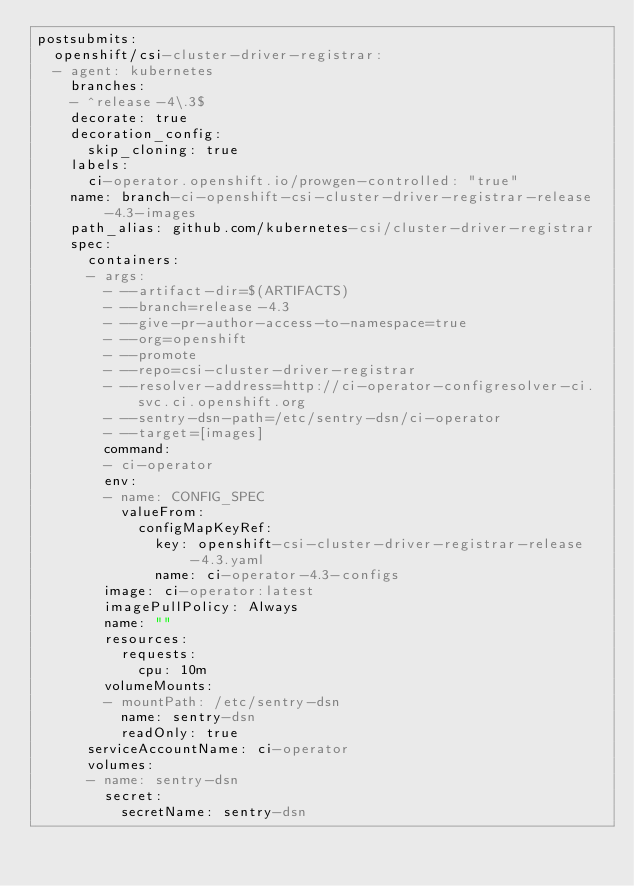Convert code to text. <code><loc_0><loc_0><loc_500><loc_500><_YAML_>postsubmits:
  openshift/csi-cluster-driver-registrar:
  - agent: kubernetes
    branches:
    - ^release-4\.3$
    decorate: true
    decoration_config:
      skip_cloning: true
    labels:
      ci-operator.openshift.io/prowgen-controlled: "true"
    name: branch-ci-openshift-csi-cluster-driver-registrar-release-4.3-images
    path_alias: github.com/kubernetes-csi/cluster-driver-registrar
    spec:
      containers:
      - args:
        - --artifact-dir=$(ARTIFACTS)
        - --branch=release-4.3
        - --give-pr-author-access-to-namespace=true
        - --org=openshift
        - --promote
        - --repo=csi-cluster-driver-registrar
        - --resolver-address=http://ci-operator-configresolver-ci.svc.ci.openshift.org
        - --sentry-dsn-path=/etc/sentry-dsn/ci-operator
        - --target=[images]
        command:
        - ci-operator
        env:
        - name: CONFIG_SPEC
          valueFrom:
            configMapKeyRef:
              key: openshift-csi-cluster-driver-registrar-release-4.3.yaml
              name: ci-operator-4.3-configs
        image: ci-operator:latest
        imagePullPolicy: Always
        name: ""
        resources:
          requests:
            cpu: 10m
        volumeMounts:
        - mountPath: /etc/sentry-dsn
          name: sentry-dsn
          readOnly: true
      serviceAccountName: ci-operator
      volumes:
      - name: sentry-dsn
        secret:
          secretName: sentry-dsn
</code> 